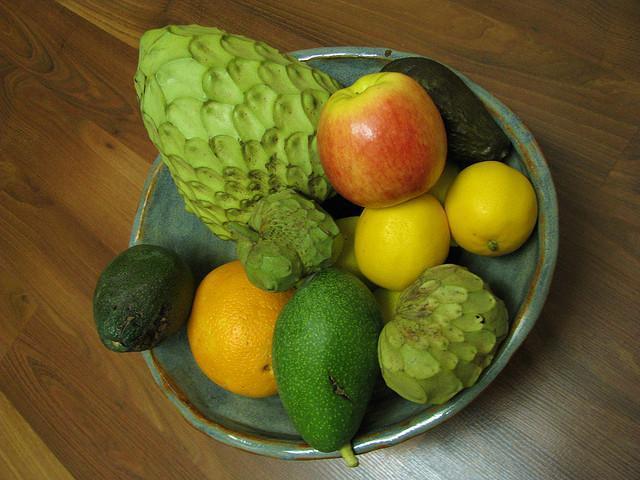How many bowls are there?
Give a very brief answer. 1. 